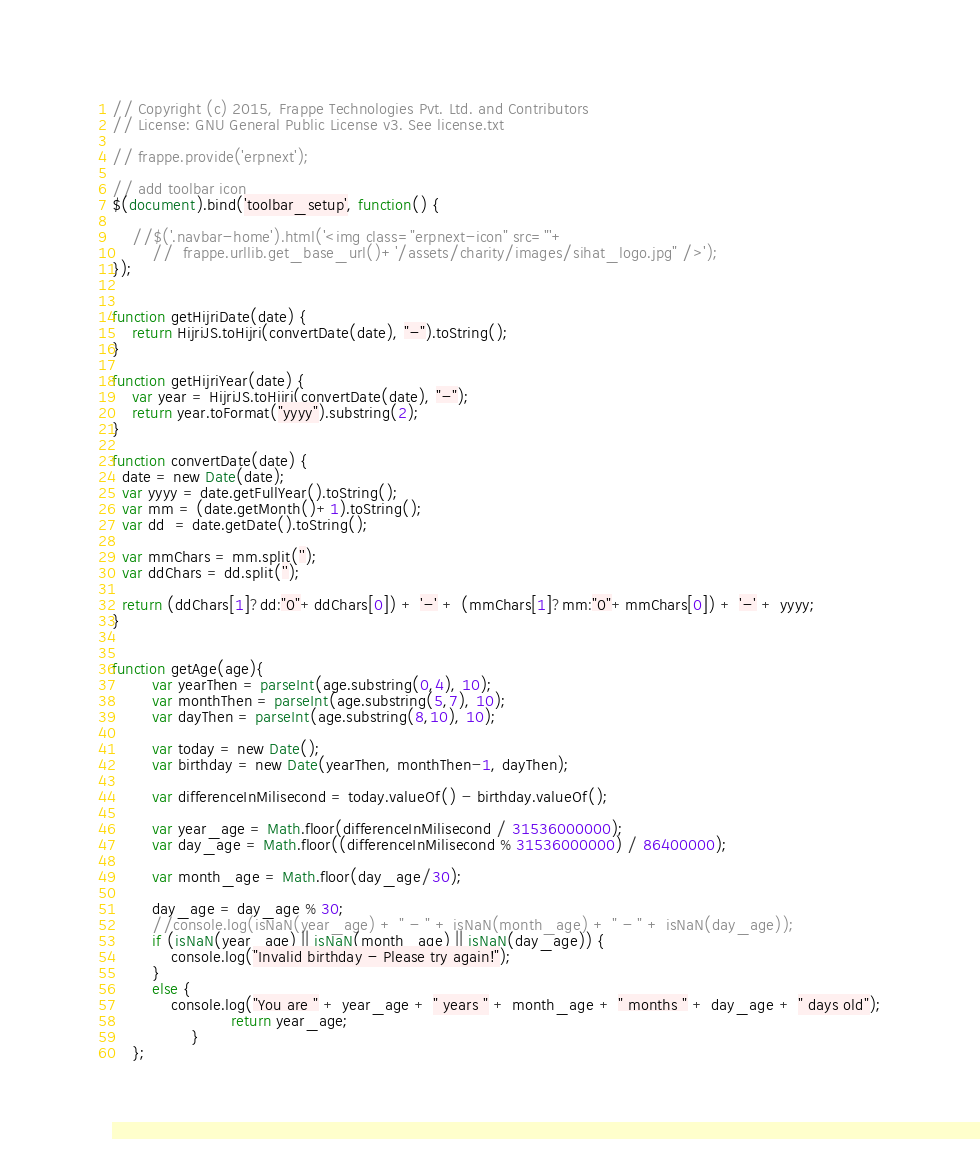Convert code to text. <code><loc_0><loc_0><loc_500><loc_500><_JavaScript_>// Copyright (c) 2015, Frappe Technologies Pvt. Ltd. and Contributors
// License: GNU General Public License v3. See license.txt

// frappe.provide('erpnext');

// add toolbar icon
$(document).bind('toolbar_setup', function() {

	//$('.navbar-home').html('<img class="erpnext-icon" src="'+
		//	frappe.urllib.get_base_url()+'/assets/charity/images/sihat_logo.jpg" />');
});


function getHijriDate(date) {
	return HijriJS.toHijri(convertDate(date), "-").toString();
}

function getHijriYear(date) {
	var year = HijriJS.toHijri(convertDate(date), "-");
	return year.toFormat("yyyy").substring(2);
}

function convertDate(date) {
  date = new Date(date);
  var yyyy = date.getFullYear().toString();
  var mm = (date.getMonth()+1).toString();
  var dd  = date.getDate().toString();

  var mmChars = mm.split('');
  var ddChars = dd.split('');

  return (ddChars[1]?dd:"0"+ddChars[0]) + '-' + (mmChars[1]?mm:"0"+mmChars[0]) + '-' + yyyy;
}


function getAge(age){
        var yearThen = parseInt(age.substring(0,4), 10);
        var monthThen = parseInt(age.substring(5,7), 10);
        var dayThen = parseInt(age.substring(8,10), 10);

        var today = new Date();
        var birthday = new Date(yearThen, monthThen-1, dayThen);

        var differenceInMilisecond = today.valueOf() - birthday.valueOf();

        var year_age = Math.floor(differenceInMilisecond / 31536000000);
        var day_age = Math.floor((differenceInMilisecond % 31536000000) / 86400000);

        var month_age = Math.floor(day_age/30);

        day_age = day_age % 30;
        //console.log(isNaN(year_age) + " - " + isNaN(month_age) + " - " + isNaN(day_age));
        if (isNaN(year_age) || isNaN(month_age) || isNaN(day_age)) {
            console.log("Invalid birthday - Please try again!");
        }
        else {
            console.log("You are " + year_age + " years " + month_age + " months " + day_age + " days old");
						return year_age;
				}
    };
</code> 